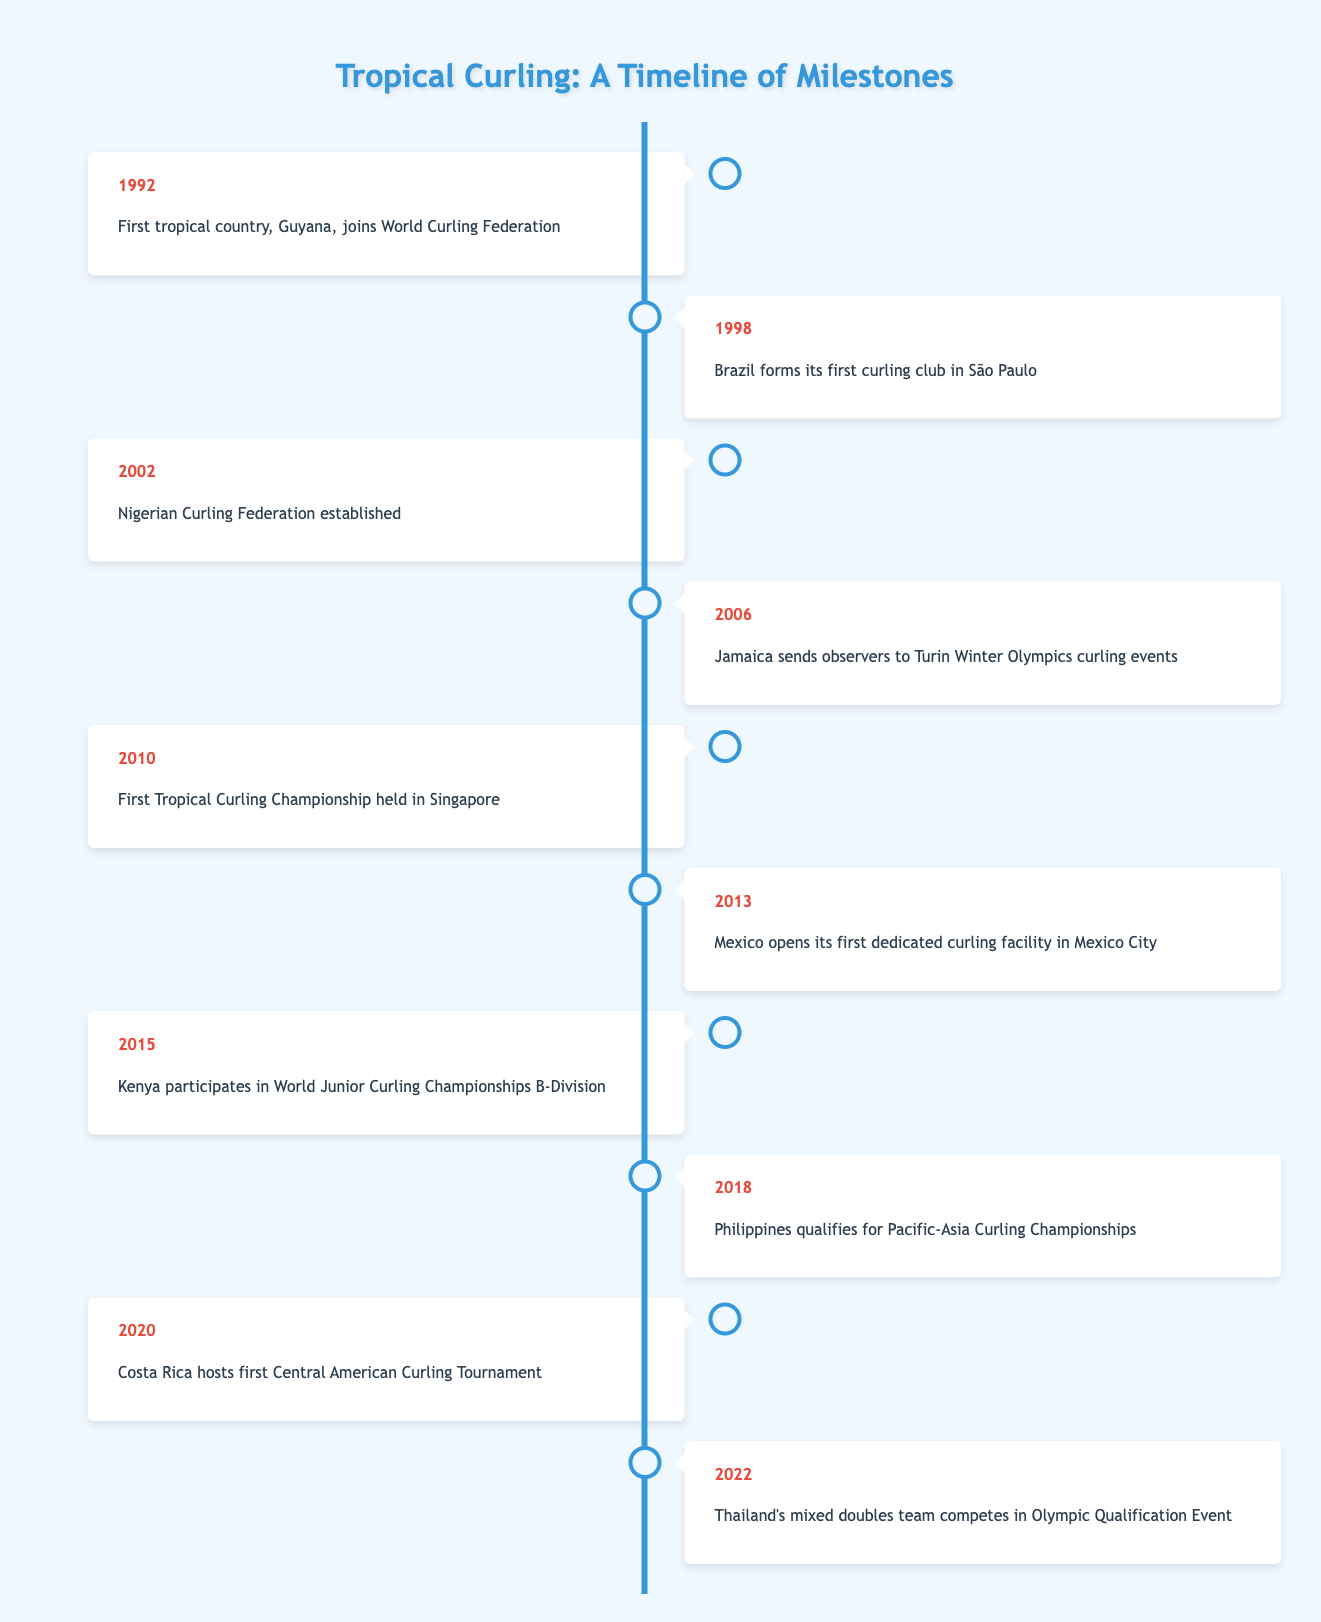What year did Guyana join the World Curling Federation? In the table, the entry for the year 1992 states that Guyana was the first tropical country to join the World Curling Federation.
Answer: 1992 Which country established its curling federation in 2002? The row for the year 2002 indicates that the Nigerian Curling Federation was established that year.
Answer: Nigeria How many years passed between Brazil forming its first curling club and the first Tropical Curling Championship? Brazil formed its first curling club in 1998 and the first Tropical Curling Championship occurred in 2010. The difference between these years: 2010 - 1998 = 12 years.
Answer: 12 Did Jamaica send observers to the Winter Olympics? According to the table, in 2006, Jamaica sent observers to the Turin Winter Olympics curling events. Therefore, the statement is true.
Answer: Yes Which countries participated in curling events between 2002 and 2022? The table displays the following countries that participated in curling events during this time frame: Nigeria (2002), Jamaica (2006), Kenya (2015), Philippines (2018), Costa Rica (2020), and Thailand (2022). This requires collating multiple entries to answer the question.
Answer: Nigeria, Jamaica, Kenya, Philippines, Costa Rica, Thailand What is the median year listed for the events? To find the median year, list the years in order: 1992, 1998, 2002, 2006, 2010, 2013, 2015, 2018, 2020, 2022. There are 10 entries, and the median is the average of the 5th and 6th entries: (2010 + 2013)/2 = 2011.5.
Answer: 2011.5 Has any tropical country hosted a curling tournament? The table indicates that Costa Rica hosted its first Central American Curling Tournament in 2020. Thus, the answer is affirmative.
Answer: Yes What was the significance of the year 2018 in the context of curling development? In 2018, the Philippines qualified for the Pacific-Asia Curling Championships, marking a significant milestone for this tropical country's curling scene.
Answer: Philippines qualified for Pacific-Asia Curling Championships 